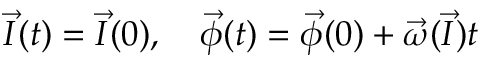<formula> <loc_0><loc_0><loc_500><loc_500>{ \vec { I } } ( t ) = { \vec { I } } ( 0 ) , \quad \vec { \phi } ( t ) = { \vec { \phi } } ( 0 ) + { \vec { \omega } } ( { \vec { I } } ) t</formula> 